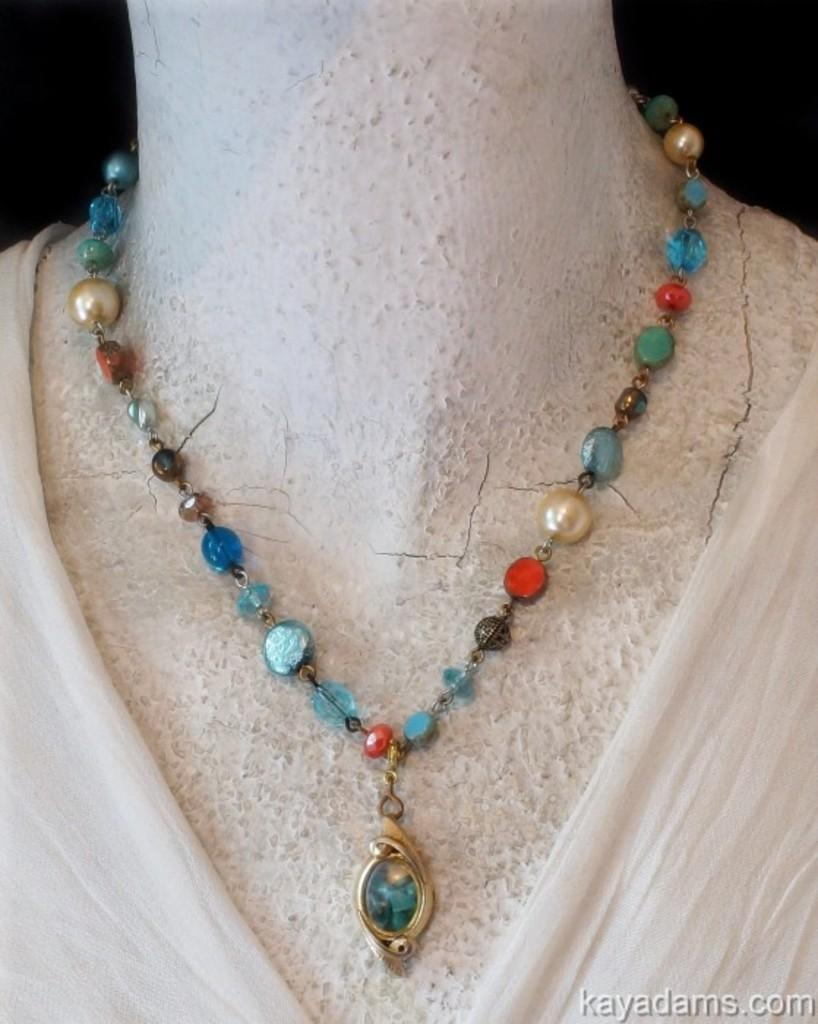What is the main subject of the image? There is a statue in the image. What is the statue wearing? The statue is wearing a necklace. Can you describe any additional features of the image? There is a watermark on the image. How many cherries are on the statue's head in the image? There are no cherries present on the statue's head in the image. What type of lead can be seen being used by the statue in the image? There is no lead or any activity involving lead depicted in the image. 